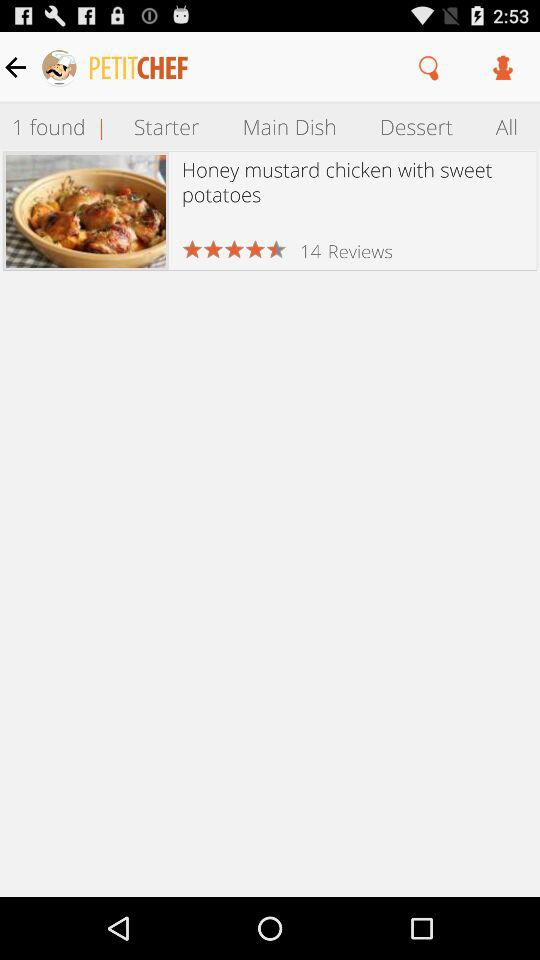What's the total number of reviews? The total number of reviews is 14. 